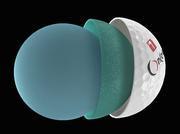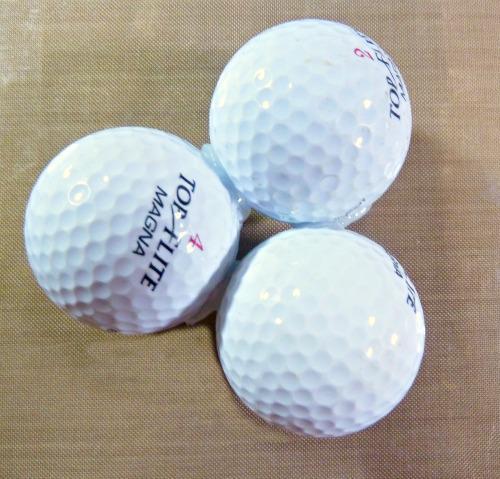The first image is the image on the left, the second image is the image on the right. Given the left and right images, does the statement "There are six white golf balls and at least some of them have T holders under or near them." hold true? Answer yes or no. No. The first image is the image on the left, the second image is the image on the right. For the images shown, is this caption "there are golf balls in sets of 3" true? Answer yes or no. Yes. 